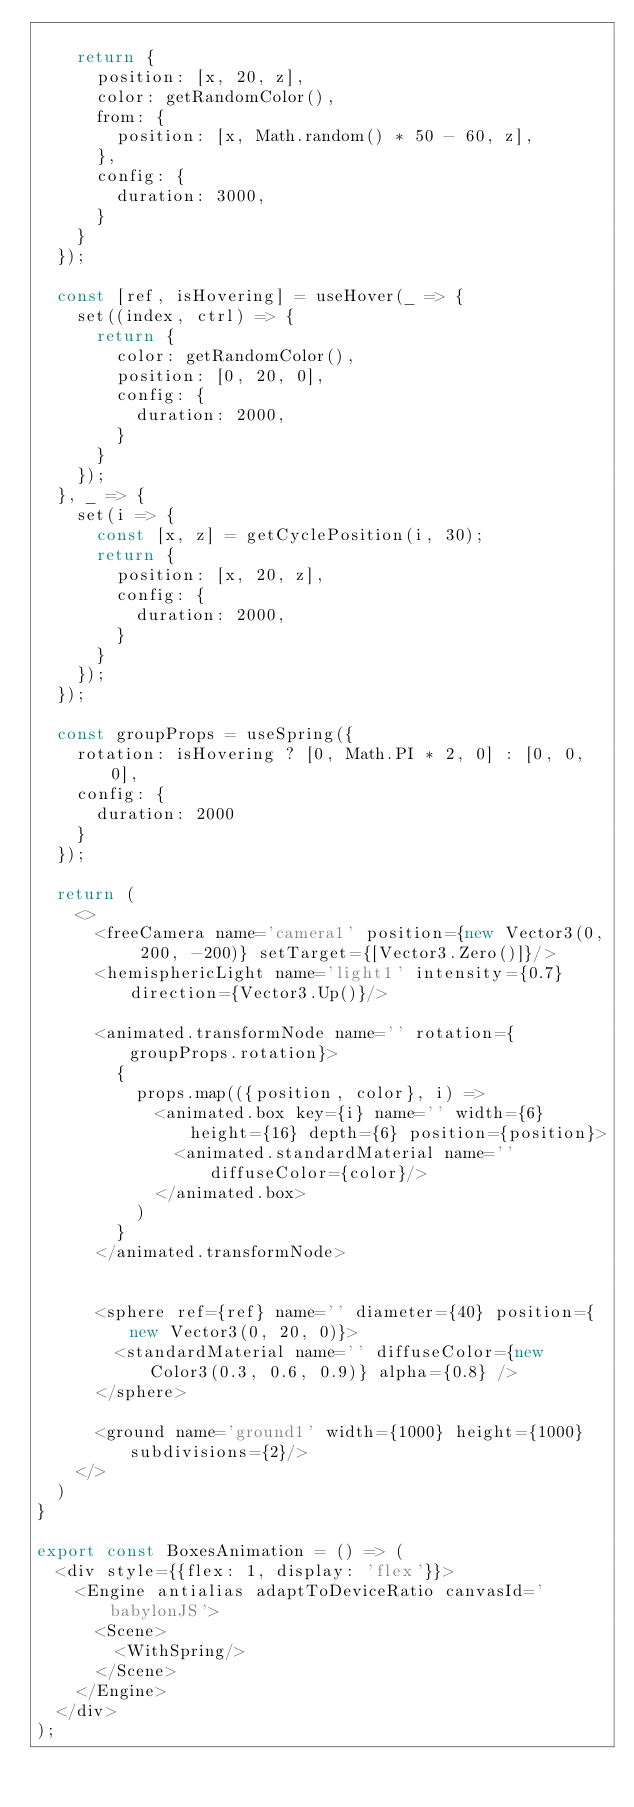<code> <loc_0><loc_0><loc_500><loc_500><_JavaScript_>
    return {
      position: [x, 20, z],
      color: getRandomColor(),
      from: {
        position: [x, Math.random() * 50 - 60, z],
      },
      config: {
        duration: 3000,
      }
    }
  });

  const [ref, isHovering] = useHover(_ => {
    set((index, ctrl) => {
      return {
        color: getRandomColor(),
        position: [0, 20, 0],
        config: {
          duration: 2000,
        }
      }
    });
  }, _ => {
    set(i => {
      const [x, z] = getCyclePosition(i, 30);
      return {
        position: [x, 20, z],
        config: {
          duration: 2000,
        }
      }
    });
  });

  const groupProps = useSpring({
    rotation: isHovering ? [0, Math.PI * 2, 0] : [0, 0, 0],
    config: {
      duration: 2000
    }
  });

  return (
    <>
      <freeCamera name='camera1' position={new Vector3(0, 200, -200)} setTarget={[Vector3.Zero()]}/>
      <hemisphericLight name='light1' intensity={0.7} direction={Vector3.Up()}/>

      <animated.transformNode name='' rotation={groupProps.rotation}>
        {
          props.map(({position, color}, i) =>
            <animated.box key={i} name='' width={6} height={16} depth={6} position={position}>
              <animated.standardMaterial name='' diffuseColor={color}/>
            </animated.box>
          )
        }
      </animated.transformNode>


      <sphere ref={ref} name='' diameter={40} position={new Vector3(0, 20, 0)}>
        <standardMaterial name='' diffuseColor={new Color3(0.3, 0.6, 0.9)} alpha={0.8} />
      </sphere>

      <ground name='ground1' width={1000} height={1000} subdivisions={2}/>
    </>
  )
}

export const BoxesAnimation = () => (
  <div style={{flex: 1, display: 'flex'}}>
    <Engine antialias adaptToDeviceRatio canvasId='babylonJS'>
      <Scene>
        <WithSpring/>
      </Scene>
    </Engine>
  </div>
);
</code> 